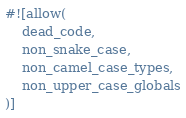Convert code to text. <code><loc_0><loc_0><loc_500><loc_500><_Rust_>#![allow(
    dead_code,
    non_snake_case,
    non_camel_case_types,
    non_upper_case_globals
)]
</code> 